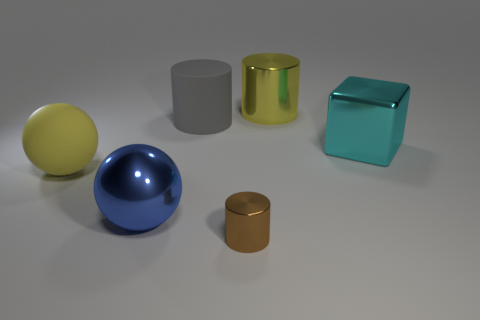Are there any other things that are the same size as the brown cylinder?
Keep it short and to the point. No. Is the yellow object behind the cyan cube made of the same material as the gray cylinder?
Offer a terse response. No. How many objects are either big cyan things or things that are on the left side of the big cyan shiny block?
Your answer should be very brief. 6. The cube that is made of the same material as the big blue thing is what color?
Your answer should be very brief. Cyan. What number of blue things have the same material as the brown object?
Your response must be concise. 1. What number of blue metal objects are there?
Offer a terse response. 1. Does the large matte object in front of the big cyan shiny thing have the same color as the metallic cylinder that is behind the blue thing?
Keep it short and to the point. Yes. There is a big metal block; what number of tiny brown things are behind it?
Give a very brief answer. 0. What material is the large thing that is the same color as the big metal cylinder?
Offer a very short reply. Rubber. Is there a brown shiny object of the same shape as the large blue shiny object?
Give a very brief answer. No. 